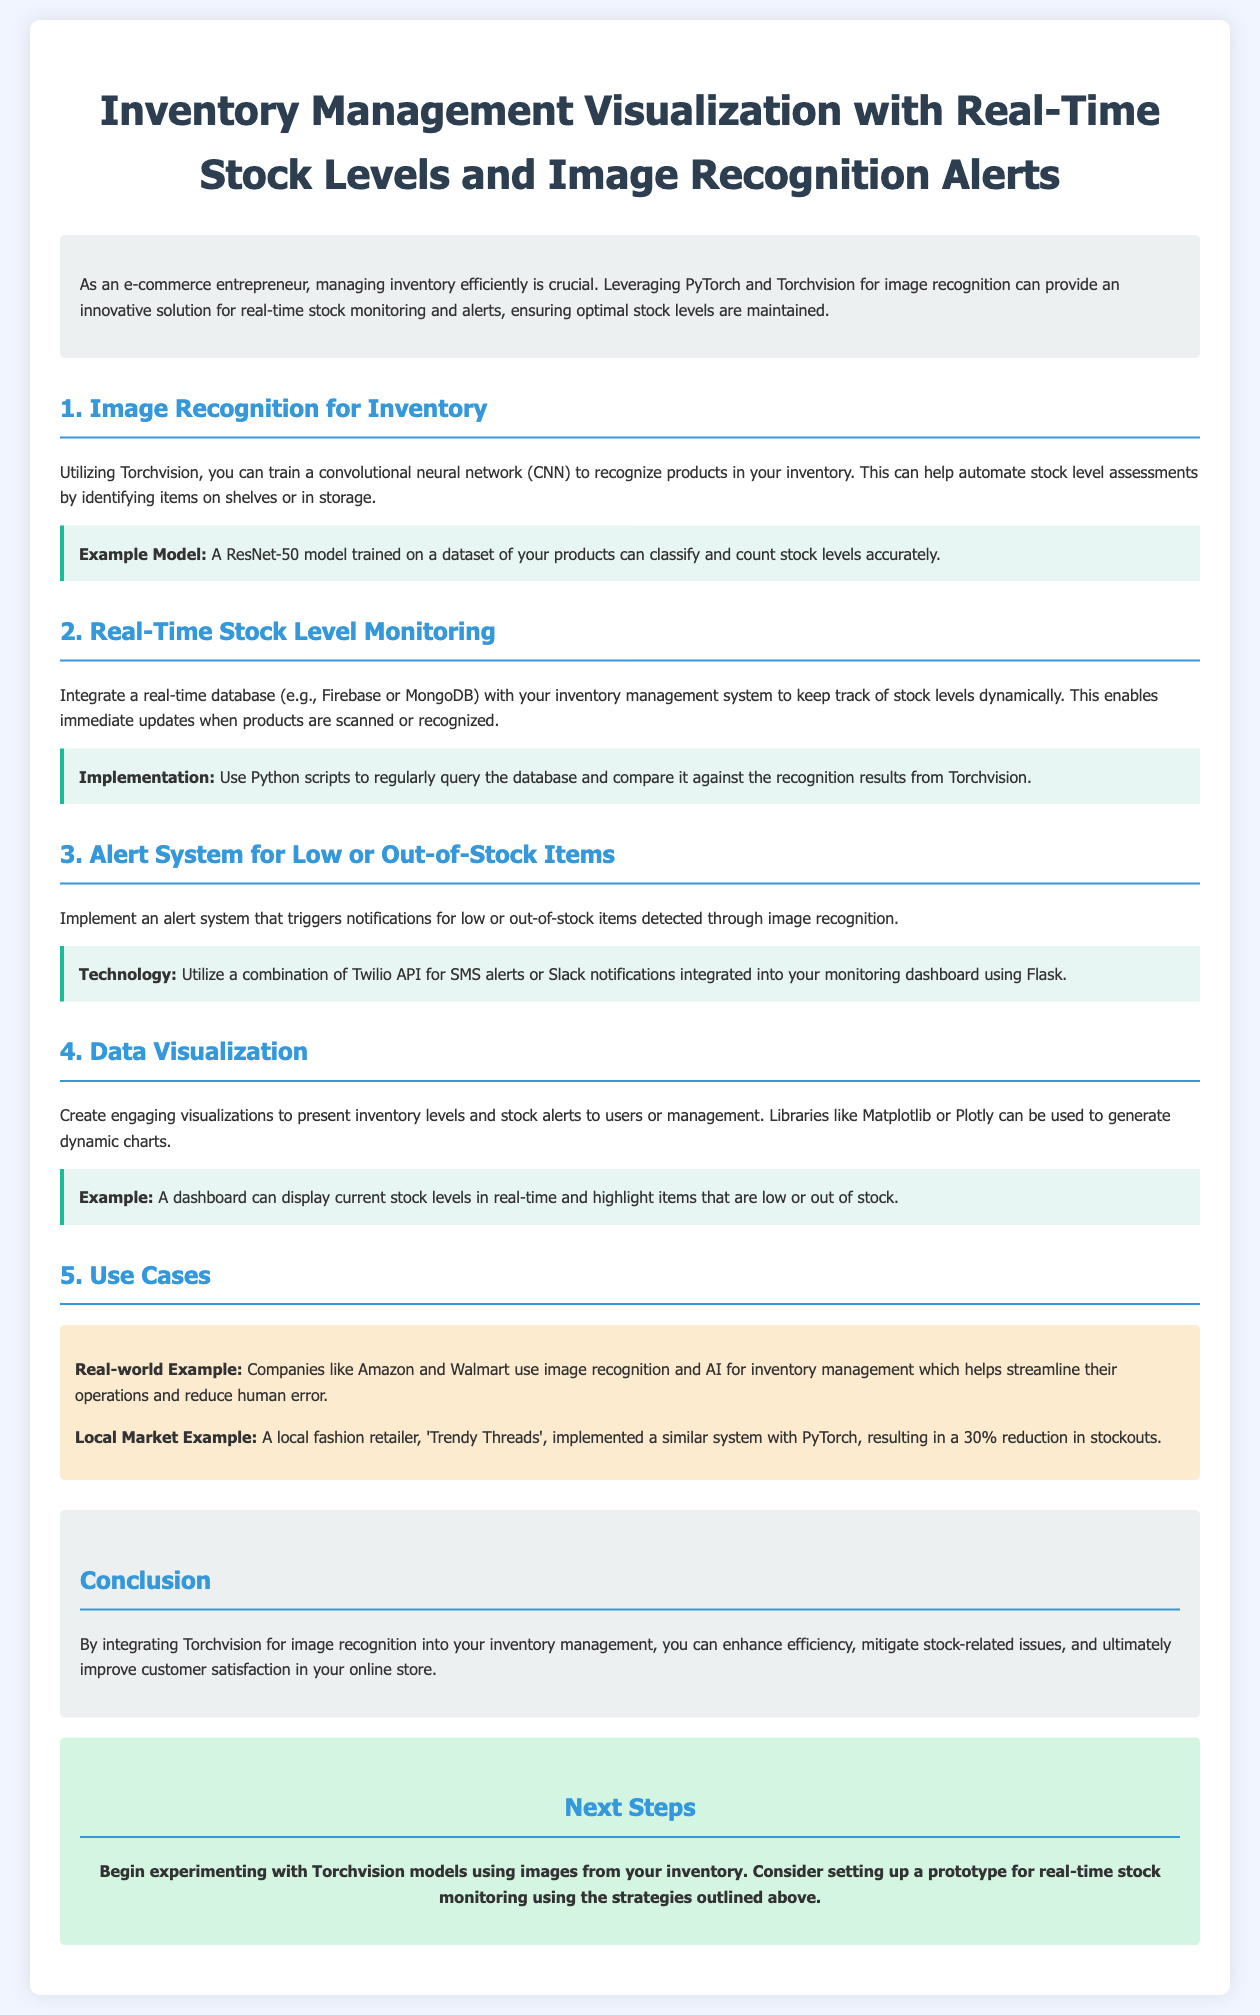What is the primary technology used for image recognition? The document mentions that PyTorch and Torchvision are the primary technologies used for image recognition.
Answer: PyTorch and Torchvision Which model is suggested for training in the document? The document suggests using a ResNet-50 model for recognizing products in inventory.
Answer: ResNet-50 What is the expected reduction in stockouts for 'Trendy Threads'? The local fashion retailer 'Trendy Threads' implemented a similar system and saw a 30% reduction in stockouts.
Answer: 30% What type of database is recommended for real-time stock level monitoring? The document recommends integrating a real-time database like Firebase or MongoDB for stock level monitoring.
Answer: Firebase or MongoDB What library is suggested for creating dynamic visualizations? The document suggests using libraries like Matplotlib or Plotly for data visualization.
Answer: Matplotlib or Plotly Which alert system technology is mentioned for notifications? The document mentions using Twilio API for SMS alerts as part of the alert system.
Answer: Twilio API What is the purpose of integrating image recognition into inventory management? The purpose is to enhance efficiency, mitigate stock-related issues, and improve customer satisfaction.
Answer: Enhance efficiency What is a real-world example given for companies using image recognition in inventory management? The document cites Amazon and Walmart as companies using image recognition and AI for inventory management.
Answer: Amazon and Walmart 